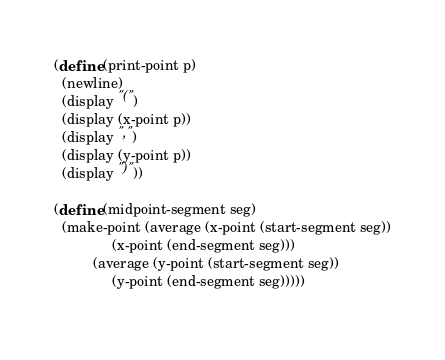Convert code to text. <code><loc_0><loc_0><loc_500><loc_500><_Scheme_>
(define (print-point p)
  (newline)
  (display "(")
  (display (x-point p))
  (display ",")
  (display (y-point p))
  (display ")"))

(define (midpoint-segment seg)
  (make-point (average (x-point (start-segment seg))
		       (x-point (end-segment seg)))
	      (average (y-point (start-segment seg))
		       (y-point (end-segment seg)))))
  
</code> 